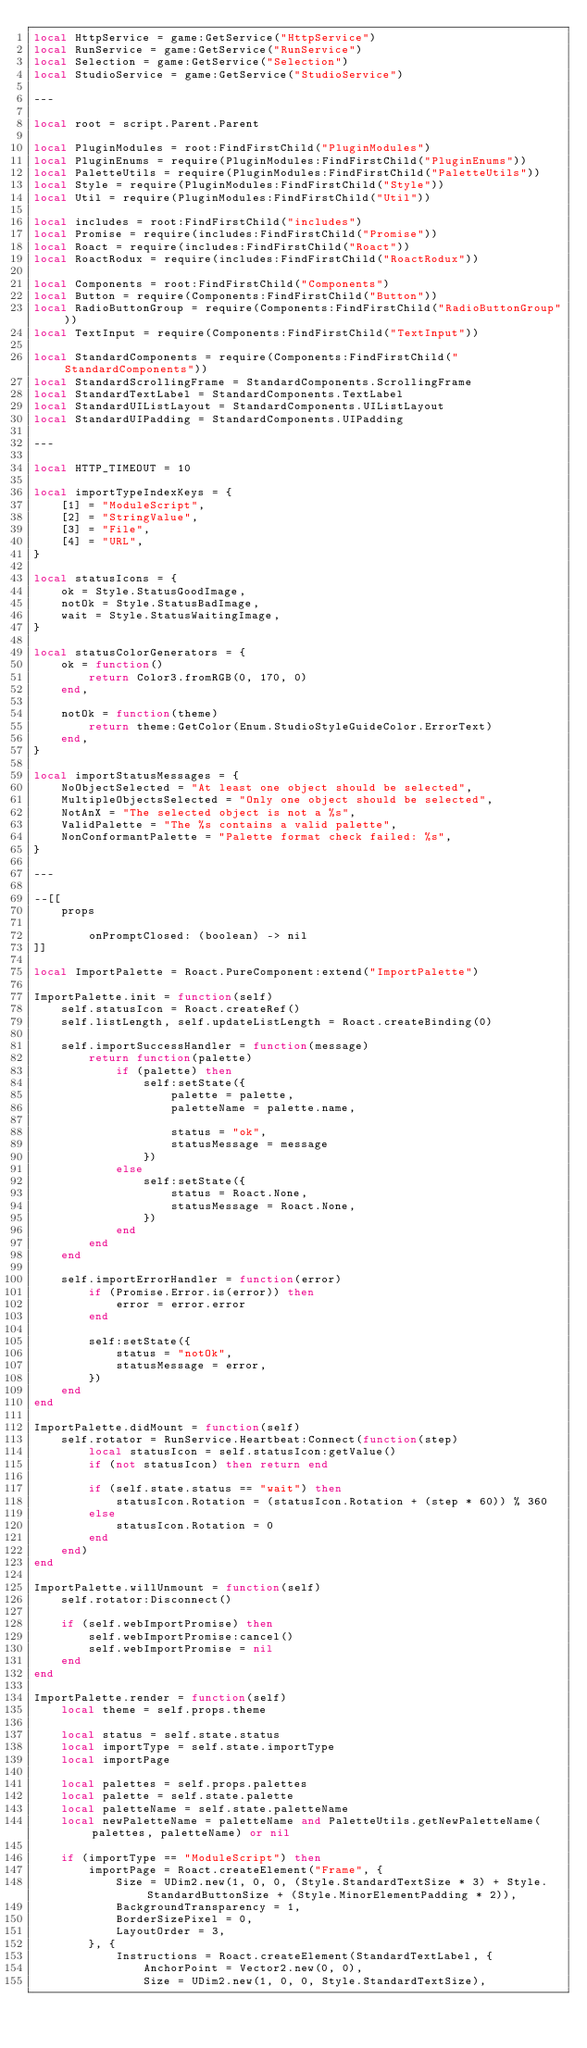<code> <loc_0><loc_0><loc_500><loc_500><_Lua_>local HttpService = game:GetService("HttpService")
local RunService = game:GetService("RunService")
local Selection = game:GetService("Selection")
local StudioService = game:GetService("StudioService")

---

local root = script.Parent.Parent

local PluginModules = root:FindFirstChild("PluginModules")
local PluginEnums = require(PluginModules:FindFirstChild("PluginEnums"))
local PaletteUtils = require(PluginModules:FindFirstChild("PaletteUtils"))
local Style = require(PluginModules:FindFirstChild("Style"))
local Util = require(PluginModules:FindFirstChild("Util"))

local includes = root:FindFirstChild("includes")
local Promise = require(includes:FindFirstChild("Promise"))
local Roact = require(includes:FindFirstChild("Roact"))
local RoactRodux = require(includes:FindFirstChild("RoactRodux"))

local Components = root:FindFirstChild("Components")
local Button = require(Components:FindFirstChild("Button"))
local RadioButtonGroup = require(Components:FindFirstChild("RadioButtonGroup"))
local TextInput = require(Components:FindFirstChild("TextInput"))

local StandardComponents = require(Components:FindFirstChild("StandardComponents"))
local StandardScrollingFrame = StandardComponents.ScrollingFrame
local StandardTextLabel = StandardComponents.TextLabel
local StandardUIListLayout = StandardComponents.UIListLayout
local StandardUIPadding = StandardComponents.UIPadding

---

local HTTP_TIMEOUT = 10

local importTypeIndexKeys = {
    [1] = "ModuleScript",
    [2] = "StringValue",
    [3] = "File",
    [4] = "URL",
}

local statusIcons = {
    ok = Style.StatusGoodImage,
    notOk = Style.StatusBadImage,
    wait = Style.StatusWaitingImage,
}

local statusColorGenerators = {
    ok = function()
        return Color3.fromRGB(0, 170, 0)
    end,

    notOk = function(theme)
        return theme:GetColor(Enum.StudioStyleGuideColor.ErrorText)
    end,
}

local importStatusMessages = {
    NoObjectSelected = "At least one object should be selected",
    MultipleObjectsSelected = "Only one object should be selected",
    NotAnX = "The selected object is not a %s",
    ValidPalette = "The %s contains a valid palette",
    NonConformantPalette = "Palette format check failed: %s",
}

---

--[[
    props

        onPromptClosed: (boolean) -> nil
]]

local ImportPalette = Roact.PureComponent:extend("ImportPalette")

ImportPalette.init = function(self)
    self.statusIcon = Roact.createRef()
    self.listLength, self.updateListLength = Roact.createBinding(0)

    self.importSuccessHandler = function(message)
        return function(palette)
            if (palette) then
                self:setState({
                    palette = palette,
                    paletteName = palette.name,
                    
                    status = "ok",
                    statusMessage = message
                })
            else
                self:setState({
                    status = Roact.None,
                    statusMessage = Roact.None,
                })
            end
        end
    end

    self.importErrorHandler = function(error)
        if (Promise.Error.is(error)) then
            error = error.error
        end

        self:setState({
            status = "notOk",
            statusMessage = error,
        })
    end
end

ImportPalette.didMount = function(self)
    self.rotator = RunService.Heartbeat:Connect(function(step)
        local statusIcon = self.statusIcon:getValue()
        if (not statusIcon) then return end

        if (self.state.status == "wait") then
            statusIcon.Rotation = (statusIcon.Rotation + (step * 60)) % 360  
        else
            statusIcon.Rotation = 0
        end
    end)
end

ImportPalette.willUnmount = function(self)
    self.rotator:Disconnect()

    if (self.webImportPromise) then
        self.webImportPromise:cancel()
        self.webImportPromise = nil
    end
end

ImportPalette.render = function(self)
    local theme = self.props.theme

    local status = self.state.status
    local importType = self.state.importType
    local importPage

    local palettes = self.props.palettes
    local palette = self.state.palette
    local paletteName = self.state.paletteName
    local newPaletteName = paletteName and PaletteUtils.getNewPaletteName(palettes, paletteName) or nil

    if (importType == "ModuleScript") then
        importPage = Roact.createElement("Frame", {
            Size = UDim2.new(1, 0, 0, (Style.StandardTextSize * 3) + Style.StandardButtonSize + (Style.MinorElementPadding * 2)),
            BackgroundTransparency = 1,
            BorderSizePixel = 0,
            LayoutOrder = 3,
        }, {
            Instructions = Roact.createElement(StandardTextLabel, {
                AnchorPoint = Vector2.new(0, 0),
                Size = UDim2.new(1, 0, 0, Style.StandardTextSize),</code> 